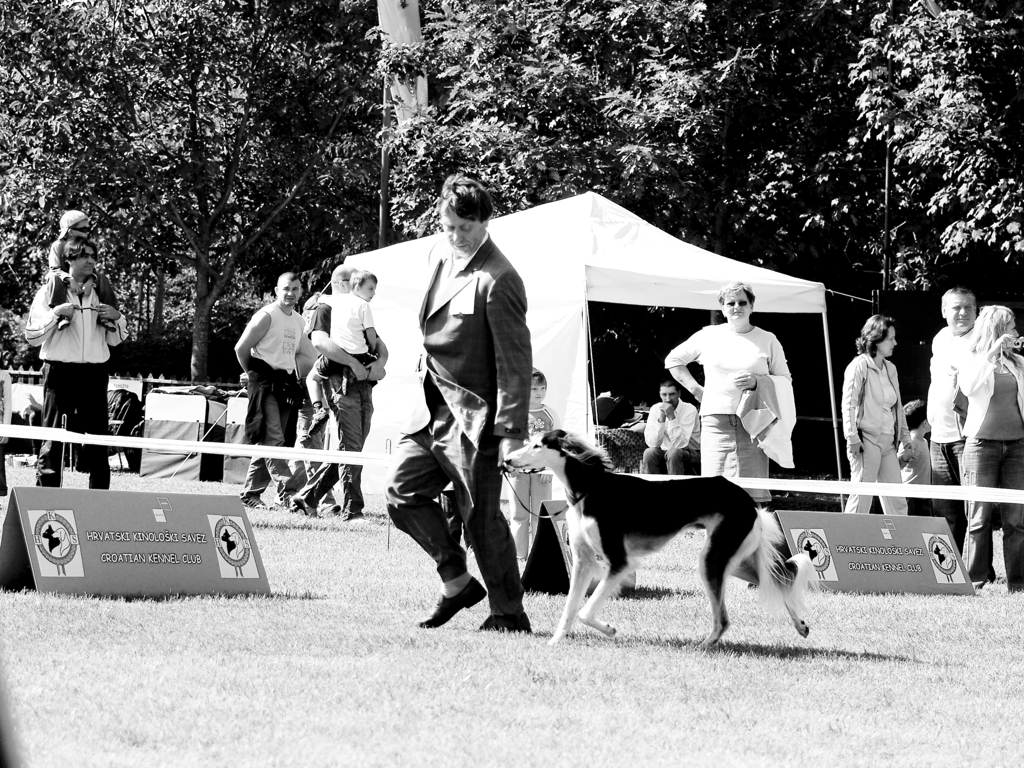Describe the emotions or mood that this image conveys. The black and white filter of the image evokes a timeless quality, giving the scene an almost nostalgic atmosphere. The posture and expressions of the people present show engagement and concentration, particularly the individual guiding the dog, who appears focused on the task. The overall mood is one of attentive participation, with spectators showing interest in the event unfolding before them. 